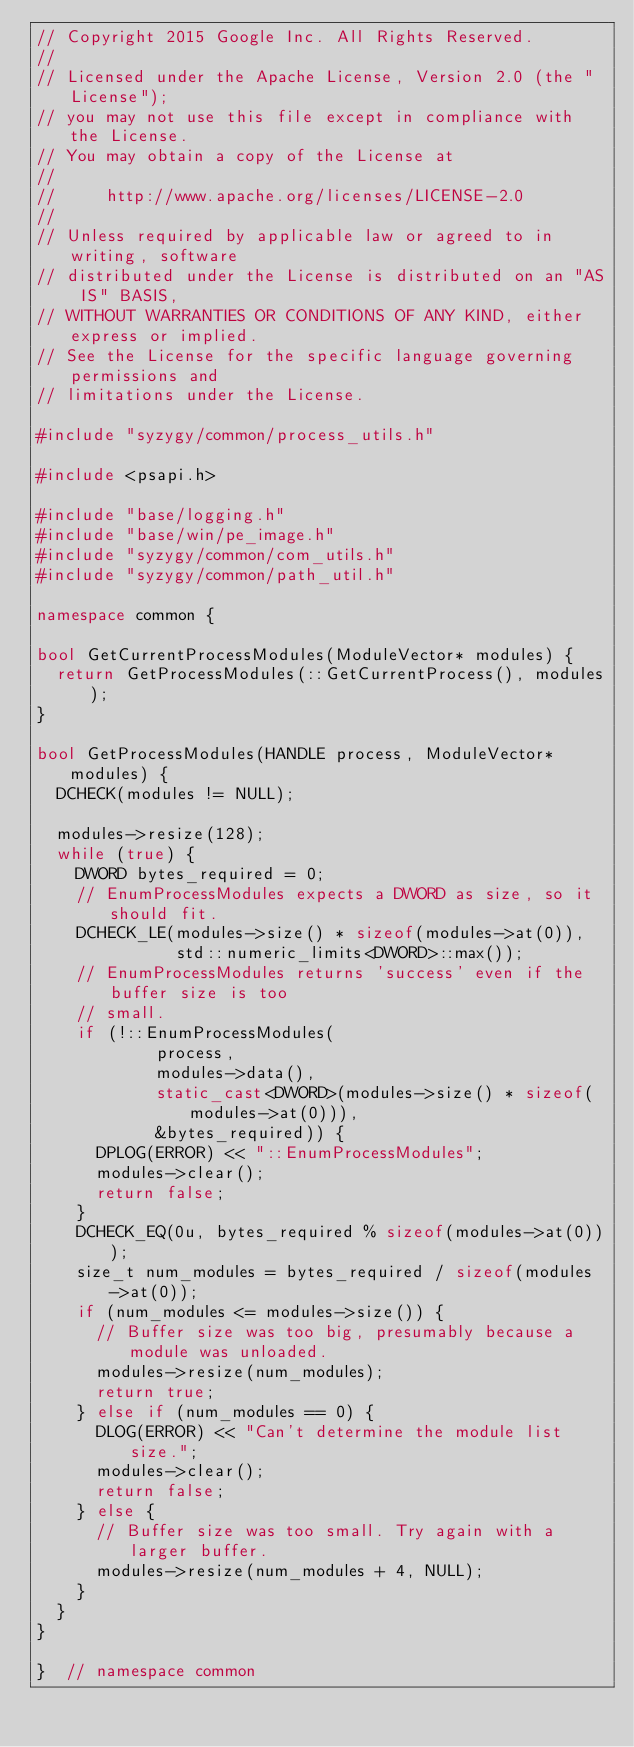<code> <loc_0><loc_0><loc_500><loc_500><_C++_>// Copyright 2015 Google Inc. All Rights Reserved.
//
// Licensed under the Apache License, Version 2.0 (the "License");
// you may not use this file except in compliance with the License.
// You may obtain a copy of the License at
//
//     http://www.apache.org/licenses/LICENSE-2.0
//
// Unless required by applicable law or agreed to in writing, software
// distributed under the License is distributed on an "AS IS" BASIS,
// WITHOUT WARRANTIES OR CONDITIONS OF ANY KIND, either express or implied.
// See the License for the specific language governing permissions and
// limitations under the License.

#include "syzygy/common/process_utils.h"

#include <psapi.h>

#include "base/logging.h"
#include "base/win/pe_image.h"
#include "syzygy/common/com_utils.h"
#include "syzygy/common/path_util.h"

namespace common {

bool GetCurrentProcessModules(ModuleVector* modules) {
  return GetProcessModules(::GetCurrentProcess(), modules);
}

bool GetProcessModules(HANDLE process, ModuleVector* modules) {
  DCHECK(modules != NULL);

  modules->resize(128);
  while (true) {
    DWORD bytes_required = 0;
    // EnumProcessModules expects a DWORD as size, so it should fit.
    DCHECK_LE(modules->size() * sizeof(modules->at(0)),
              std::numeric_limits<DWORD>::max());
    // EnumProcessModules returns 'success' even if the buffer size is too
    // small.
    if (!::EnumProcessModules(
            process,
            modules->data(),
            static_cast<DWORD>(modules->size() * sizeof(modules->at(0))),
            &bytes_required)) {
      DPLOG(ERROR) << "::EnumProcessModules";
      modules->clear();
      return false;
    }
    DCHECK_EQ(0u, bytes_required % sizeof(modules->at(0)));
    size_t num_modules = bytes_required / sizeof(modules->at(0));
    if (num_modules <= modules->size()) {
      // Buffer size was too big, presumably because a module was unloaded.
      modules->resize(num_modules);
      return true;
    } else if (num_modules == 0) {
      DLOG(ERROR) << "Can't determine the module list size.";
      modules->clear();
      return false;
    } else {
      // Buffer size was too small. Try again with a larger buffer.
      modules->resize(num_modules + 4, NULL);
    }
  }
}

}  // namespace common
</code> 